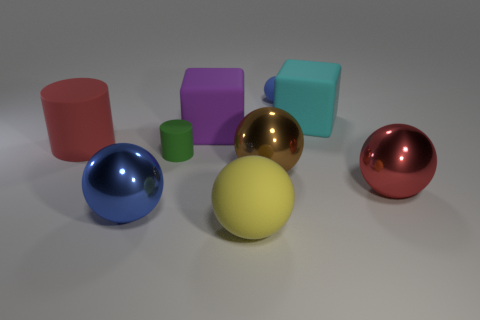Subtract all green balls. Subtract all green blocks. How many balls are left? 5 Subtract all cylinders. How many objects are left? 7 Add 6 big red spheres. How many big red spheres exist? 7 Subtract 0 green balls. How many objects are left? 9 Subtract all yellow metal cubes. Subtract all green rubber things. How many objects are left? 8 Add 9 purple blocks. How many purple blocks are left? 10 